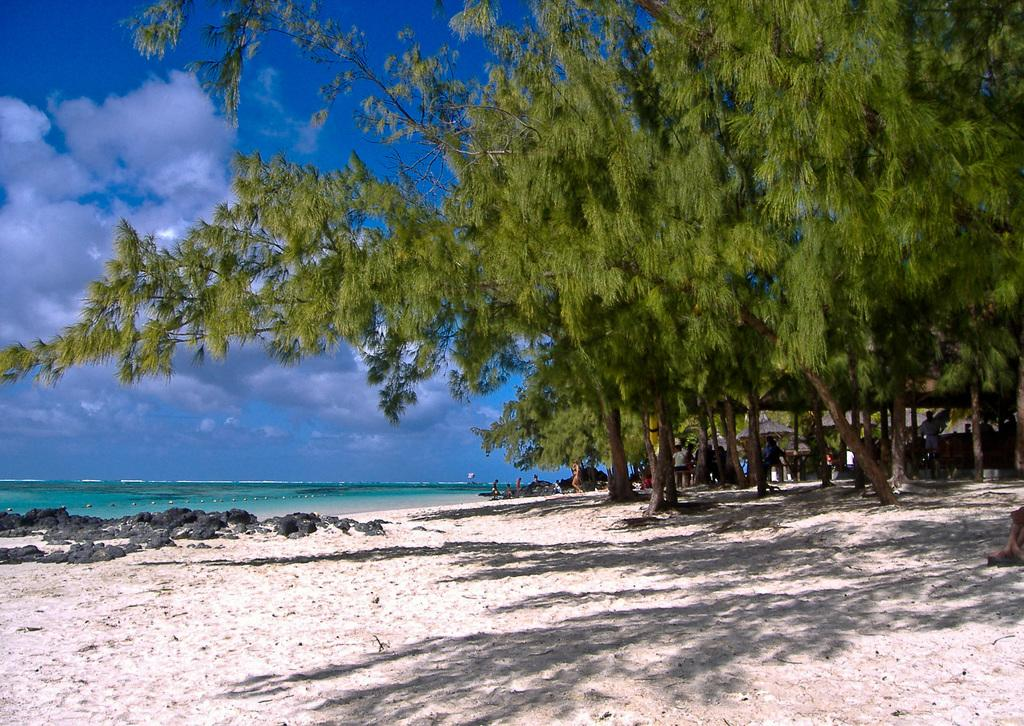What can be seen in the sky in the image? The sky is visible in the image, and there are clouds present. What type of natural vegetation is in the image? Trees are present in the image. What is the water boy doing in the image? There is a water boy in the image, but it is not clear what specific action he is performing. How many people are in the image? There are people in the image, but the exact number is not specified. Can you see a donkey looking out of a window in the image? There is no donkey or window present in the image. 